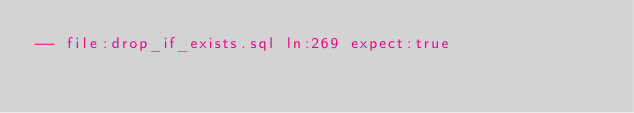Convert code to text. <code><loc_0><loc_0><loc_500><loc_500><_SQL_>-- file:drop_if_exists.sql ln:269 expect:true</code> 